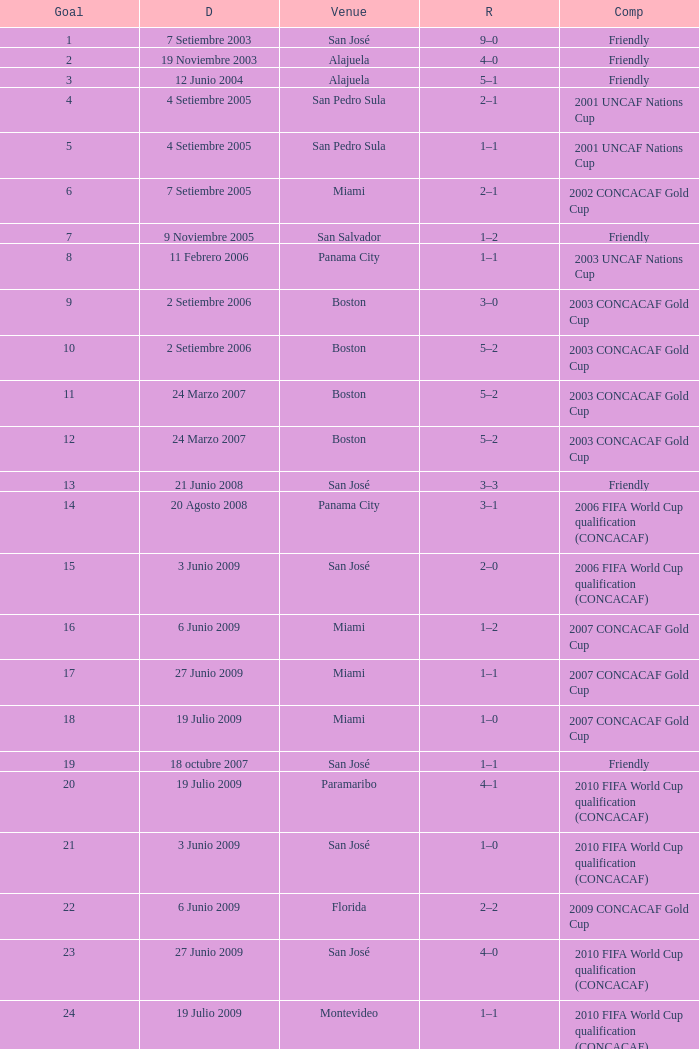How many goals were scored on 21 Junio 2008? 1.0. 